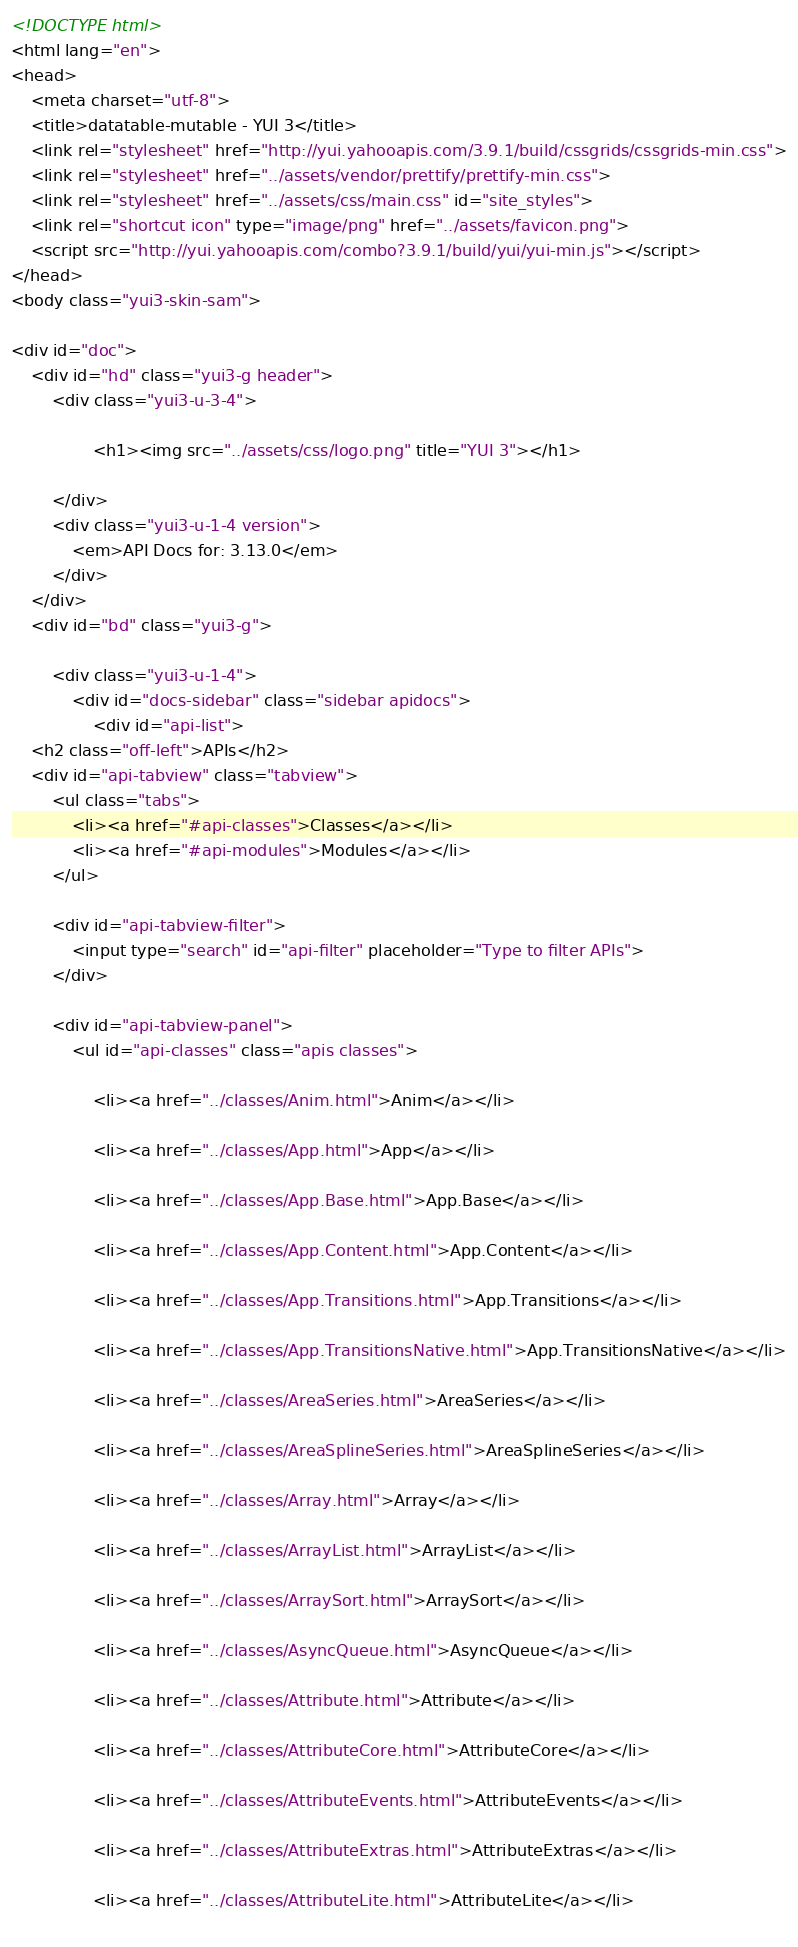Convert code to text. <code><loc_0><loc_0><loc_500><loc_500><_HTML_><!DOCTYPE html>
<html lang="en">
<head>
    <meta charset="utf-8">
    <title>datatable-mutable - YUI 3</title>
    <link rel="stylesheet" href="http://yui.yahooapis.com/3.9.1/build/cssgrids/cssgrids-min.css">
    <link rel="stylesheet" href="../assets/vendor/prettify/prettify-min.css">
    <link rel="stylesheet" href="../assets/css/main.css" id="site_styles">
    <link rel="shortcut icon" type="image/png" href="../assets/favicon.png">
    <script src="http://yui.yahooapis.com/combo?3.9.1/build/yui/yui-min.js"></script>
</head>
<body class="yui3-skin-sam">

<div id="doc">
    <div id="hd" class="yui3-g header">
        <div class="yui3-u-3-4">
            
                <h1><img src="../assets/css/logo.png" title="YUI 3"></h1>
            
        </div>
        <div class="yui3-u-1-4 version">
            <em>API Docs for: 3.13.0</em>
        </div>
    </div>
    <div id="bd" class="yui3-g">

        <div class="yui3-u-1-4">
            <div id="docs-sidebar" class="sidebar apidocs">
                <div id="api-list">
    <h2 class="off-left">APIs</h2>
    <div id="api-tabview" class="tabview">
        <ul class="tabs">
            <li><a href="#api-classes">Classes</a></li>
            <li><a href="#api-modules">Modules</a></li>
        </ul>

        <div id="api-tabview-filter">
            <input type="search" id="api-filter" placeholder="Type to filter APIs">
        </div>

        <div id="api-tabview-panel">
            <ul id="api-classes" class="apis classes">
            
                <li><a href="../classes/Anim.html">Anim</a></li>
            
                <li><a href="../classes/App.html">App</a></li>
            
                <li><a href="../classes/App.Base.html">App.Base</a></li>
            
                <li><a href="../classes/App.Content.html">App.Content</a></li>
            
                <li><a href="../classes/App.Transitions.html">App.Transitions</a></li>
            
                <li><a href="../classes/App.TransitionsNative.html">App.TransitionsNative</a></li>
            
                <li><a href="../classes/AreaSeries.html">AreaSeries</a></li>
            
                <li><a href="../classes/AreaSplineSeries.html">AreaSplineSeries</a></li>
            
                <li><a href="../classes/Array.html">Array</a></li>
            
                <li><a href="../classes/ArrayList.html">ArrayList</a></li>
            
                <li><a href="../classes/ArraySort.html">ArraySort</a></li>
            
                <li><a href="../classes/AsyncQueue.html">AsyncQueue</a></li>
            
                <li><a href="../classes/Attribute.html">Attribute</a></li>
            
                <li><a href="../classes/AttributeCore.html">AttributeCore</a></li>
            
                <li><a href="../classes/AttributeEvents.html">AttributeEvents</a></li>
            
                <li><a href="../classes/AttributeExtras.html">AttributeExtras</a></li>
            
                <li><a href="../classes/AttributeLite.html">AttributeLite</a></li>
            </code> 